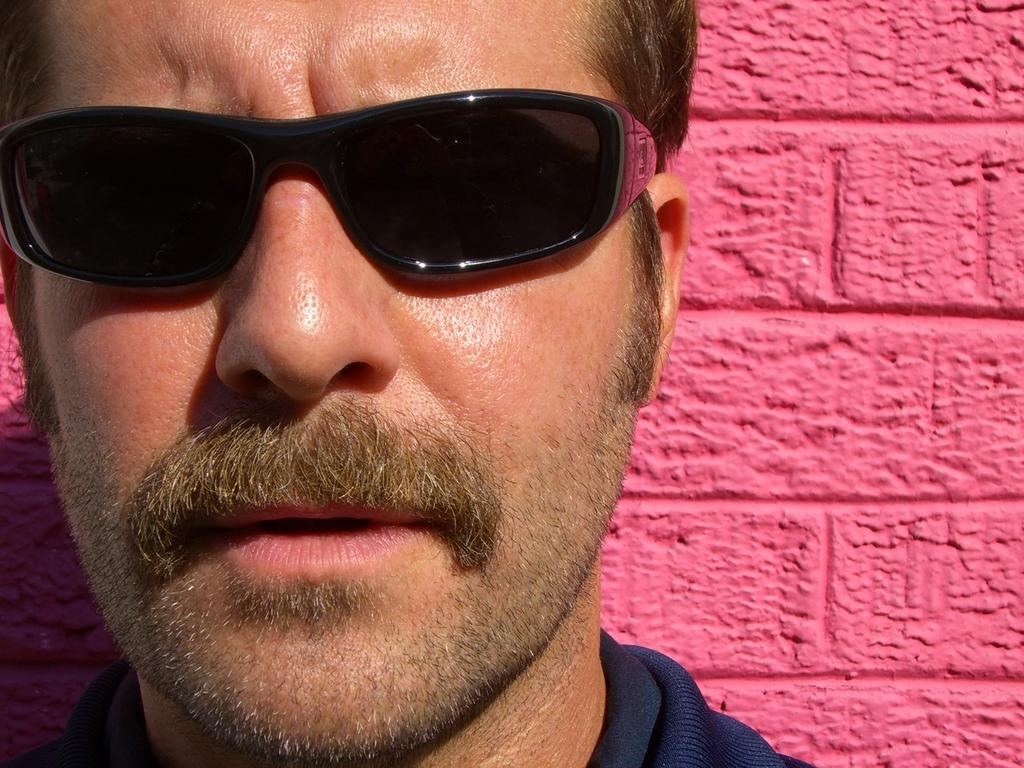Who or what is the main subject in the image? There is a person in the image. What is the person wearing that is noticeable? The person is wearing black color spectacles. What can be seen behind the person in the image? There is a pink color wall behind the person. How many loaves of bread are on the edge of the wall in the image? There are no loaves of bread present in the image. 